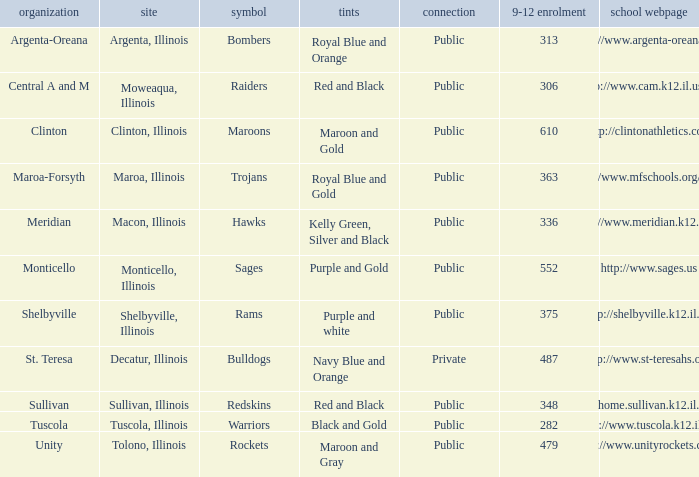What colors can you see players from Tolono, Illinois wearing? Maroon and Gray. 